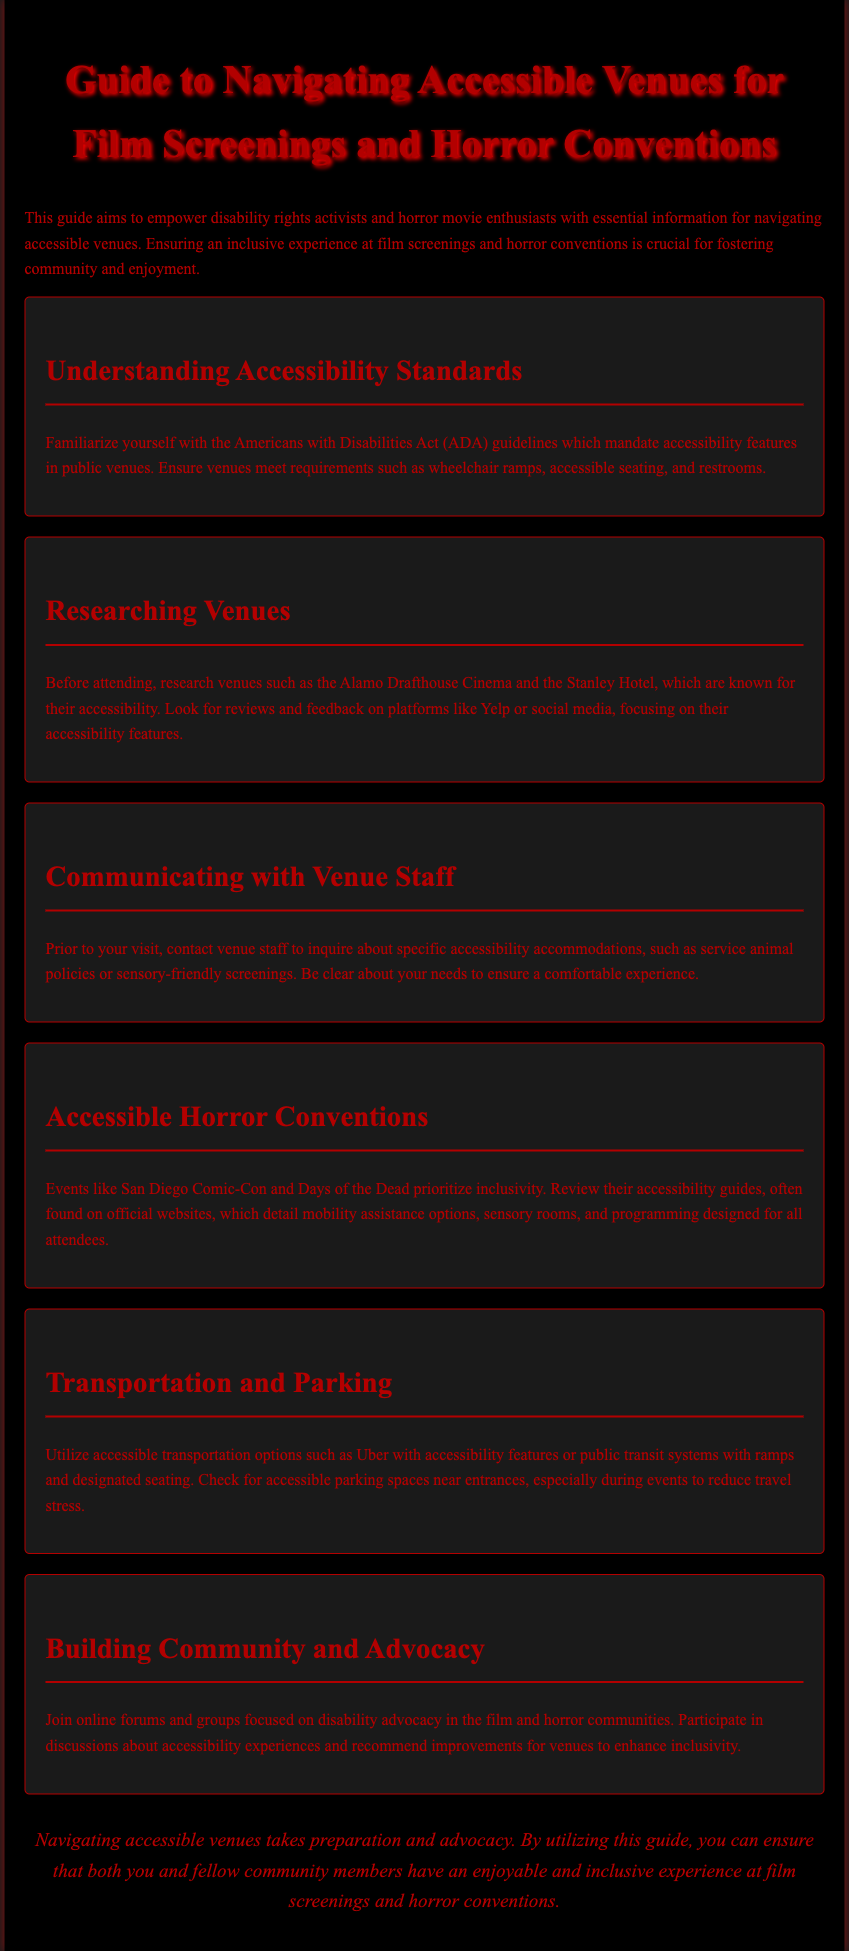What are the ADA guidelines? The ADA guidelines mandate accessibility features in public venues, ensuring compliance with requirements such as wheelchair ramps, accessible seating, and restrooms.
Answer: Americans with Disabilities Act Name a venue known for its accessibility. The document mentions venues that are recognized for their accessibility features, providing readers with options for viewing films or attending conventions.
Answer: Alamo Drafthouse Cinema What should you inquire about when contacting venue staff? The document suggests specific inquiries to make with venue staff before attending events, addressing various accommodations that can enhance accessibility.
Answer: Accessibility accommodations Which horror convention prioritizes inclusivity? The document lists a convention that emphasizes inclusiveness and accessibility for all attendees.
Answer: San Diego Comic-Con What transportation options should be utilized? The guide emphasizes the importance of selecting certain transportation options that are equipped to accommodate individuals with disabilities.
Answer: Accessible transportation options What type of rooms are encouraged for sensory comfort? The document outlines specific spaces dedicated to enhancing the comfort of attendees with sensory sensitivities, which can be particularly valuable at larger events.
Answer: Sensory rooms What online platforms can be used for venue research? The guide recommends using particular online resources to gather information about venue accessibility, aiding in informed decision-making.
Answer: Yelp or social media What community activity is encouraged for advocacy? Participation in specific discussions or forums is highlighted as a way to strengthen community ties and promote disability rights in film and horror settings.
Answer: Online forums and groups 